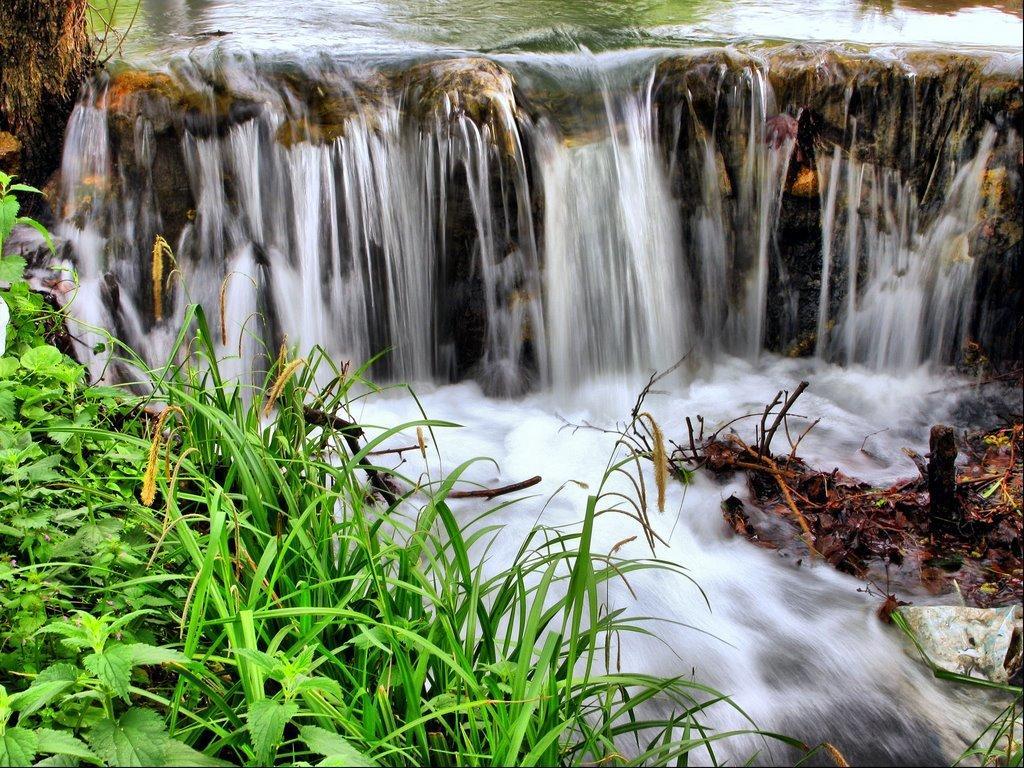Please provide a concise description of this image. In this image we can see some plants, grass which is in green color, there is water fall and in the background of the image there is water. 